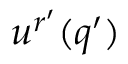<formula> <loc_0><loc_0><loc_500><loc_500>u ^ { r ^ { \prime } } ( q ^ { \prime } )</formula> 